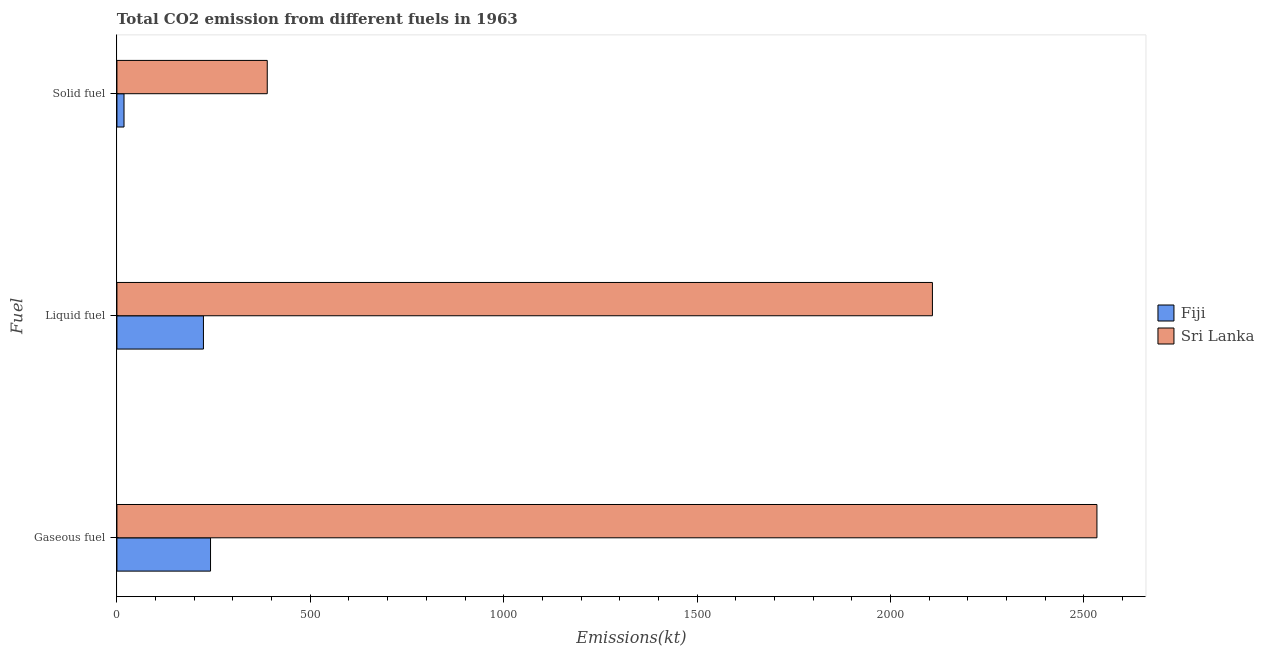How many groups of bars are there?
Offer a very short reply. 3. Are the number of bars per tick equal to the number of legend labels?
Provide a succinct answer. Yes. How many bars are there on the 2nd tick from the top?
Give a very brief answer. 2. How many bars are there on the 2nd tick from the bottom?
Offer a very short reply. 2. What is the label of the 2nd group of bars from the top?
Make the answer very short. Liquid fuel. What is the amount of co2 emissions from gaseous fuel in Fiji?
Your response must be concise. 242.02. Across all countries, what is the maximum amount of co2 emissions from gaseous fuel?
Provide a short and direct response. 2533.9. Across all countries, what is the minimum amount of co2 emissions from gaseous fuel?
Offer a very short reply. 242.02. In which country was the amount of co2 emissions from gaseous fuel maximum?
Keep it short and to the point. Sri Lanka. In which country was the amount of co2 emissions from liquid fuel minimum?
Provide a short and direct response. Fiji. What is the total amount of co2 emissions from liquid fuel in the graph?
Your answer should be compact. 2332.21. What is the difference between the amount of co2 emissions from liquid fuel in Sri Lanka and that in Fiji?
Your answer should be very brief. 1884.84. What is the difference between the amount of co2 emissions from liquid fuel in Sri Lanka and the amount of co2 emissions from gaseous fuel in Fiji?
Provide a succinct answer. 1866.5. What is the average amount of co2 emissions from liquid fuel per country?
Your response must be concise. 1166.11. What is the difference between the amount of co2 emissions from liquid fuel and amount of co2 emissions from gaseous fuel in Fiji?
Ensure brevity in your answer.  -18.33. What is the ratio of the amount of co2 emissions from liquid fuel in Fiji to that in Sri Lanka?
Provide a short and direct response. 0.11. Is the amount of co2 emissions from solid fuel in Fiji less than that in Sri Lanka?
Your response must be concise. Yes. Is the difference between the amount of co2 emissions from gaseous fuel in Sri Lanka and Fiji greater than the difference between the amount of co2 emissions from liquid fuel in Sri Lanka and Fiji?
Offer a terse response. Yes. What is the difference between the highest and the second highest amount of co2 emissions from liquid fuel?
Your answer should be very brief. 1884.84. What is the difference between the highest and the lowest amount of co2 emissions from liquid fuel?
Provide a succinct answer. 1884.84. Is the sum of the amount of co2 emissions from liquid fuel in Fiji and Sri Lanka greater than the maximum amount of co2 emissions from gaseous fuel across all countries?
Keep it short and to the point. No. What does the 1st bar from the top in Gaseous fuel represents?
Make the answer very short. Sri Lanka. What does the 1st bar from the bottom in Liquid fuel represents?
Provide a succinct answer. Fiji. Is it the case that in every country, the sum of the amount of co2 emissions from gaseous fuel and amount of co2 emissions from liquid fuel is greater than the amount of co2 emissions from solid fuel?
Offer a terse response. Yes. How many countries are there in the graph?
Give a very brief answer. 2. Does the graph contain any zero values?
Your response must be concise. No. Does the graph contain grids?
Offer a terse response. No. How many legend labels are there?
Offer a terse response. 2. What is the title of the graph?
Give a very brief answer. Total CO2 emission from different fuels in 1963. Does "Bolivia" appear as one of the legend labels in the graph?
Your answer should be compact. No. What is the label or title of the X-axis?
Your response must be concise. Emissions(kt). What is the label or title of the Y-axis?
Your answer should be compact. Fuel. What is the Emissions(kt) in Fiji in Gaseous fuel?
Keep it short and to the point. 242.02. What is the Emissions(kt) of Sri Lanka in Gaseous fuel?
Your response must be concise. 2533.9. What is the Emissions(kt) in Fiji in Liquid fuel?
Your answer should be compact. 223.69. What is the Emissions(kt) in Sri Lanka in Liquid fuel?
Offer a terse response. 2108.53. What is the Emissions(kt) of Fiji in Solid fuel?
Provide a short and direct response. 18.34. What is the Emissions(kt) in Sri Lanka in Solid fuel?
Offer a terse response. 388.7. Across all Fuel, what is the maximum Emissions(kt) in Fiji?
Provide a succinct answer. 242.02. Across all Fuel, what is the maximum Emissions(kt) of Sri Lanka?
Keep it short and to the point. 2533.9. Across all Fuel, what is the minimum Emissions(kt) in Fiji?
Give a very brief answer. 18.34. Across all Fuel, what is the minimum Emissions(kt) of Sri Lanka?
Ensure brevity in your answer.  388.7. What is the total Emissions(kt) of Fiji in the graph?
Provide a short and direct response. 484.04. What is the total Emissions(kt) of Sri Lanka in the graph?
Give a very brief answer. 5031.12. What is the difference between the Emissions(kt) of Fiji in Gaseous fuel and that in Liquid fuel?
Give a very brief answer. 18.34. What is the difference between the Emissions(kt) of Sri Lanka in Gaseous fuel and that in Liquid fuel?
Your answer should be compact. 425.37. What is the difference between the Emissions(kt) of Fiji in Gaseous fuel and that in Solid fuel?
Your answer should be very brief. 223.69. What is the difference between the Emissions(kt) in Sri Lanka in Gaseous fuel and that in Solid fuel?
Your answer should be very brief. 2145.2. What is the difference between the Emissions(kt) of Fiji in Liquid fuel and that in Solid fuel?
Your answer should be very brief. 205.35. What is the difference between the Emissions(kt) in Sri Lanka in Liquid fuel and that in Solid fuel?
Offer a very short reply. 1719.82. What is the difference between the Emissions(kt) in Fiji in Gaseous fuel and the Emissions(kt) in Sri Lanka in Liquid fuel?
Offer a terse response. -1866.5. What is the difference between the Emissions(kt) in Fiji in Gaseous fuel and the Emissions(kt) in Sri Lanka in Solid fuel?
Provide a succinct answer. -146.68. What is the difference between the Emissions(kt) of Fiji in Liquid fuel and the Emissions(kt) of Sri Lanka in Solid fuel?
Make the answer very short. -165.01. What is the average Emissions(kt) of Fiji per Fuel?
Ensure brevity in your answer.  161.35. What is the average Emissions(kt) of Sri Lanka per Fuel?
Keep it short and to the point. 1677.04. What is the difference between the Emissions(kt) in Fiji and Emissions(kt) in Sri Lanka in Gaseous fuel?
Provide a short and direct response. -2291.88. What is the difference between the Emissions(kt) in Fiji and Emissions(kt) in Sri Lanka in Liquid fuel?
Give a very brief answer. -1884.84. What is the difference between the Emissions(kt) of Fiji and Emissions(kt) of Sri Lanka in Solid fuel?
Make the answer very short. -370.37. What is the ratio of the Emissions(kt) of Fiji in Gaseous fuel to that in Liquid fuel?
Give a very brief answer. 1.08. What is the ratio of the Emissions(kt) in Sri Lanka in Gaseous fuel to that in Liquid fuel?
Keep it short and to the point. 1.2. What is the ratio of the Emissions(kt) of Sri Lanka in Gaseous fuel to that in Solid fuel?
Provide a succinct answer. 6.52. What is the ratio of the Emissions(kt) of Fiji in Liquid fuel to that in Solid fuel?
Provide a short and direct response. 12.2. What is the ratio of the Emissions(kt) in Sri Lanka in Liquid fuel to that in Solid fuel?
Offer a terse response. 5.42. What is the difference between the highest and the second highest Emissions(kt) of Fiji?
Your answer should be compact. 18.34. What is the difference between the highest and the second highest Emissions(kt) of Sri Lanka?
Your response must be concise. 425.37. What is the difference between the highest and the lowest Emissions(kt) of Fiji?
Give a very brief answer. 223.69. What is the difference between the highest and the lowest Emissions(kt) of Sri Lanka?
Give a very brief answer. 2145.2. 